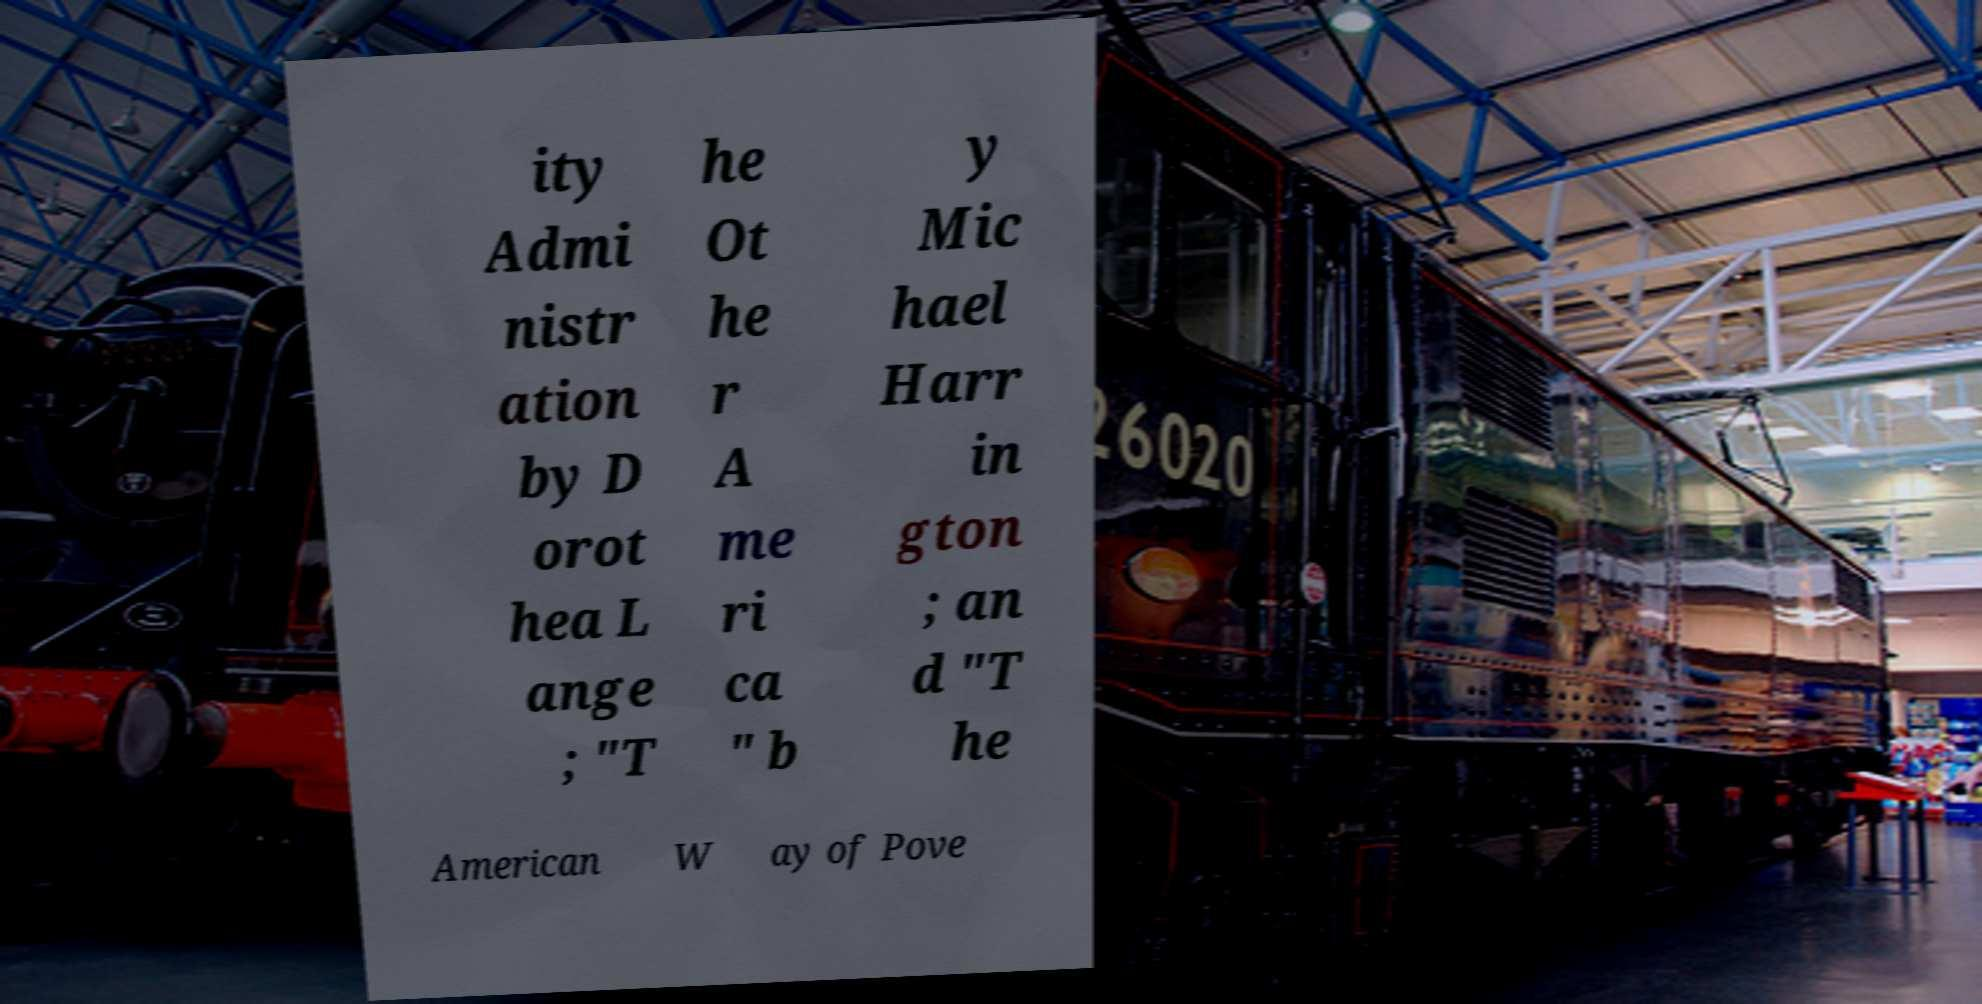For documentation purposes, I need the text within this image transcribed. Could you provide that? ity Admi nistr ation by D orot hea L ange ; "T he Ot he r A me ri ca " b y Mic hael Harr in gton ; an d "T he American W ay of Pove 